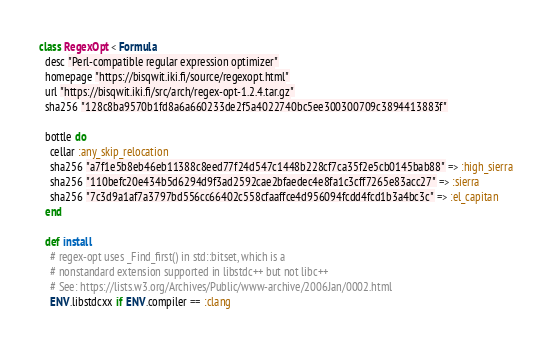<code> <loc_0><loc_0><loc_500><loc_500><_Ruby_>class RegexOpt < Formula
  desc "Perl-compatible regular expression optimizer"
  homepage "https://bisqwit.iki.fi/source/regexopt.html"
  url "https://bisqwit.iki.fi/src/arch/regex-opt-1.2.4.tar.gz"
  sha256 "128c8ba9570b1fd8a6a660233de2f5a4022740bc5ee300300709c3894413883f"

  bottle do
    cellar :any_skip_relocation
    sha256 "a7f1e5b8eb46eb11388c8eed77f24d547c1448b228cf7ca35f2e5cb0145bab88" => :high_sierra
    sha256 "110befc20e434b5d6294d9f3ad2592cae2bfaedec4e8fa1c3cff7265e83acc27" => :sierra
    sha256 "7c3d9a1af7a3797bd556cc66402c558cfaaffce4d956094fcdd4fcd1b3a4bc3c" => :el_capitan
  end

  def install
    # regex-opt uses _Find_first() in std::bitset, which is a
    # nonstandard extension supported in libstdc++ but not libc++
    # See: https://lists.w3.org/Archives/Public/www-archive/2006Jan/0002.html
    ENV.libstdcxx if ENV.compiler == :clang
</code> 